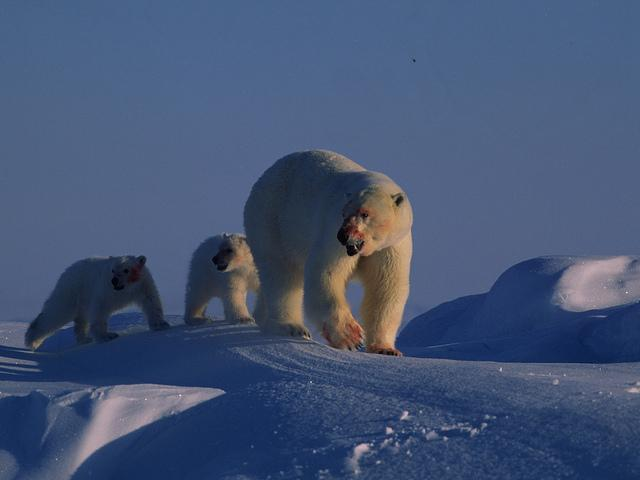Red on this bears face comes from it's what? Please explain your reasoning. prey. The polar bear must have just eaten a meal of another animal which is its prey. 